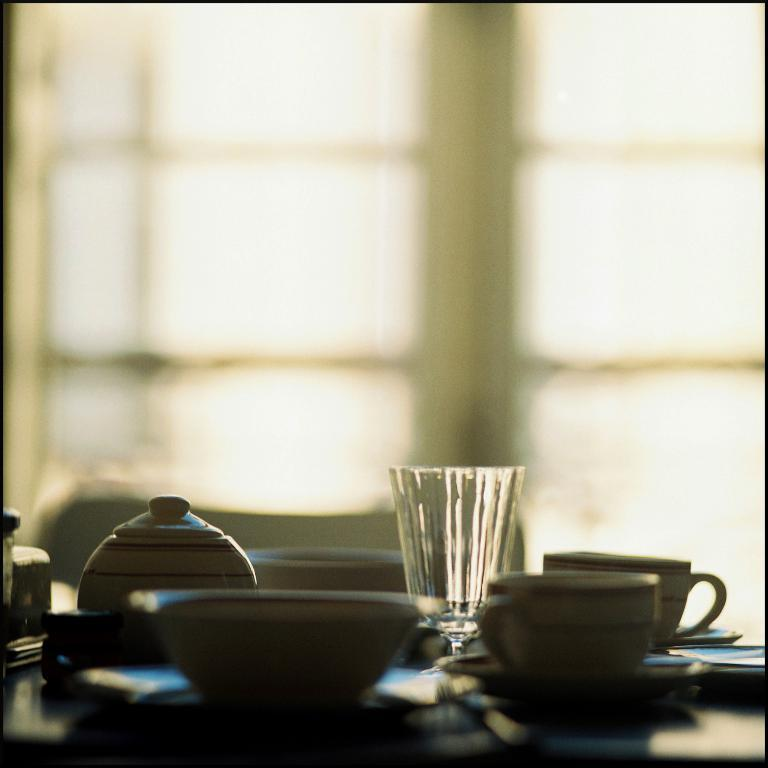What type of container is visible in the image? There is a glass in the image. What other containers can be seen in the image? There is a bowl and cups visible in the image. Where are the glass, bowl, and cups located in the image? The glass, bowl, and cups are on a table. What type of holiday is being celebrated in the image? There is no indication of a holiday being celebrated in the image. What organization is responsible for the items on the table in the image? There is no organization mentioned or implied in the image. 